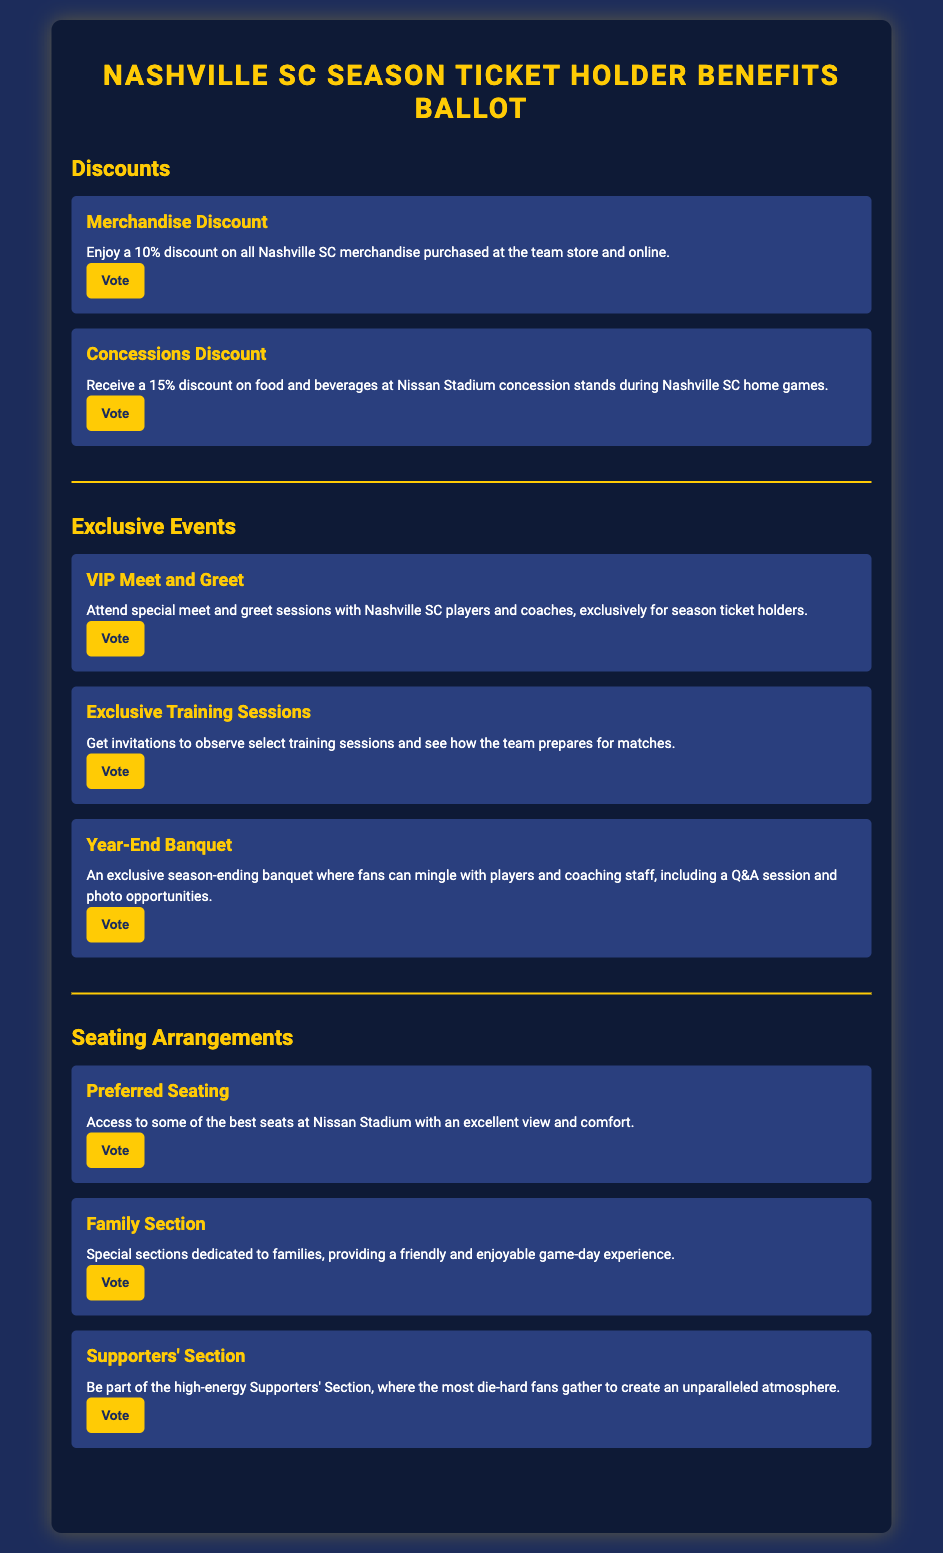What discount do season ticket holders receive on merchandise? The document specifies that season ticket holders enjoy a 10% discount on all Nashville SC merchandise purchased at the team store and online.
Answer: 10% What is the discount percentage on concessions? According to the document, season ticket holders receive a 15% discount on food and beverages at Nissan Stadium concession stands during home games.
Answer: 15% What exclusive event allows fans to meet players and coaches? The document mentions that there is a VIP Meet and Greet allowing season ticket holders to attend special sessions with players and coaches.
Answer: VIP Meet and Greet What type of seating is available for families? The document states that there are special sections dedicated to families, providing a friendly game-day experience.
Answer: Family Section What is a benefit of the Supporters' Section? The document describes the Supporters' Section as a high-energy area where the most die-hard fans gather to create an unparalleled atmosphere.
Answer: High-energy atmosphere How many exclusive events are listed in the document? By counting the exclusive events detailed in the document, there are three events mentioned, including the VIP Meet and Greet, Exclusive Training Sessions, and Year-End Banquet.
Answer: Three What offer is available for observing training sessions? Season ticket holders receive invitations to observe select training sessions and see how the team prepares for matches.
Answer: Invitations to training sessions What kind of banquet is exclusive to season ticket holders? The document outlines a Year-End Banquet that is exclusive to season ticket holders, where they can mingle with players and coaching staff.
Answer: Year-End Banquet 